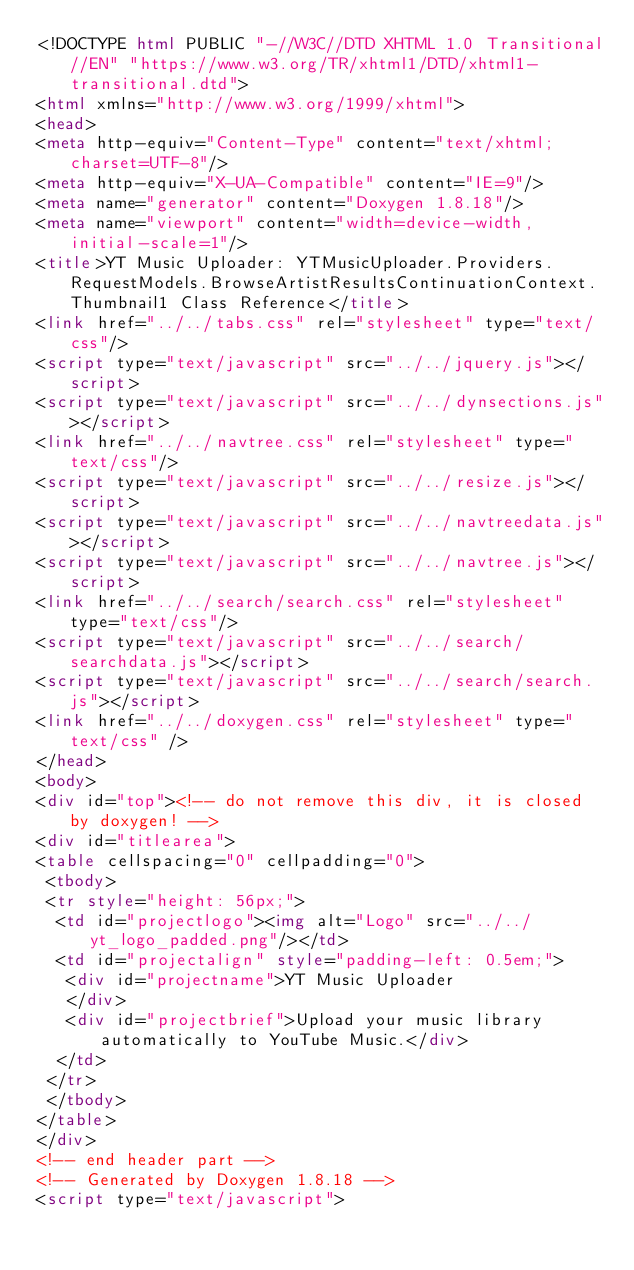Convert code to text. <code><loc_0><loc_0><loc_500><loc_500><_HTML_><!DOCTYPE html PUBLIC "-//W3C//DTD XHTML 1.0 Transitional//EN" "https://www.w3.org/TR/xhtml1/DTD/xhtml1-transitional.dtd">
<html xmlns="http://www.w3.org/1999/xhtml">
<head>
<meta http-equiv="Content-Type" content="text/xhtml;charset=UTF-8"/>
<meta http-equiv="X-UA-Compatible" content="IE=9"/>
<meta name="generator" content="Doxygen 1.8.18"/>
<meta name="viewport" content="width=device-width, initial-scale=1"/>
<title>YT Music Uploader: YTMusicUploader.Providers.RequestModels.BrowseArtistResultsContinuationContext.Thumbnail1 Class Reference</title>
<link href="../../tabs.css" rel="stylesheet" type="text/css"/>
<script type="text/javascript" src="../../jquery.js"></script>
<script type="text/javascript" src="../../dynsections.js"></script>
<link href="../../navtree.css" rel="stylesheet" type="text/css"/>
<script type="text/javascript" src="../../resize.js"></script>
<script type="text/javascript" src="../../navtreedata.js"></script>
<script type="text/javascript" src="../../navtree.js"></script>
<link href="../../search/search.css" rel="stylesheet" type="text/css"/>
<script type="text/javascript" src="../../search/searchdata.js"></script>
<script type="text/javascript" src="../../search/search.js"></script>
<link href="../../doxygen.css" rel="stylesheet" type="text/css" />
</head>
<body>
<div id="top"><!-- do not remove this div, it is closed by doxygen! -->
<div id="titlearea">
<table cellspacing="0" cellpadding="0">
 <tbody>
 <tr style="height: 56px;">
  <td id="projectlogo"><img alt="Logo" src="../../yt_logo_padded.png"/></td>
  <td id="projectalign" style="padding-left: 0.5em;">
   <div id="projectname">YT Music Uploader
   </div>
   <div id="projectbrief">Upload your music library automatically to YouTube Music.</div>
  </td>
 </tr>
 </tbody>
</table>
</div>
<!-- end header part -->
<!-- Generated by Doxygen 1.8.18 -->
<script type="text/javascript"></code> 